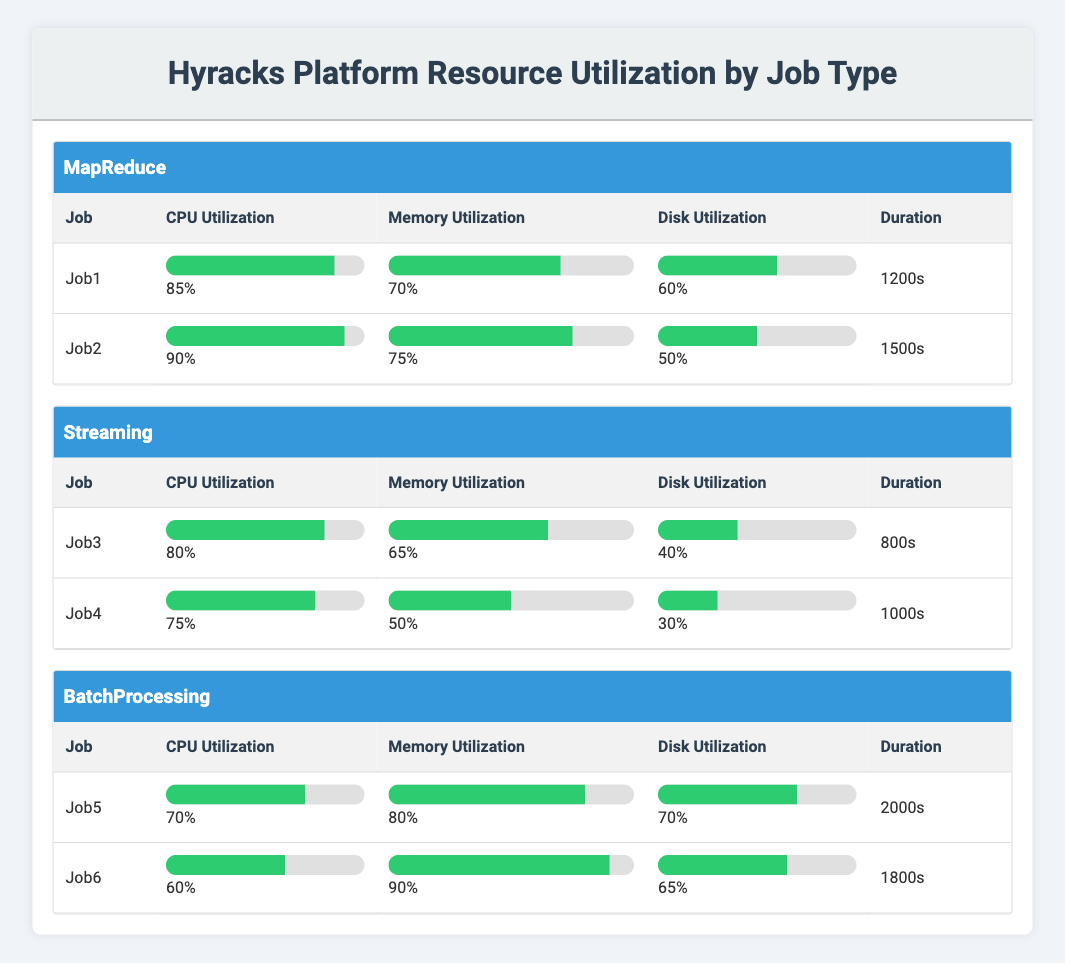What is the CPU utilization of Job2? The table shows the CPU utilization of Job2 under the MapReduce section. According to the data presented, Job2 has a CPU utilization of 90%.
Answer: 90% Which job has the highest memory utilization among the Streaming jobs? By examining the Streaming job section, Job3 has a memory utilization of 65%, and Job4 has a memory utilization of 50%. Therefore, Job3 has the highest memory utilization among the two.
Answer: Job3 What is the average disk utilization for all jobs in the BatchProcessing category? The disk utilization values for BatchProcessing jobs are 70% (Job5) and 65% (Job6). To calculate the average, we add these values: 70% + 65% = 135%. Then we divide by 2 (the number of jobs): 135% / 2 = 67.5%.
Answer: 67.5% Does Job4 have a higher disk utilization than Job3? Job3 has a disk utilization of 40%, while Job4 has a disk utilization of 30%. Comparing these two values shows that Job4 does not have a higher disk utilization than Job3.
Answer: No Which job has the longest duration among all jobs? Reviewing the durations of all jobs, Job5 has the longest duration of 2000 seconds. Job1 is 1200 seconds, Job2 is 1500 seconds, Job3 is 800 seconds, Job4 is 1000 seconds, and Job6 is 1800 seconds. Hence, Job5 is the longest.
Answer: Job5 